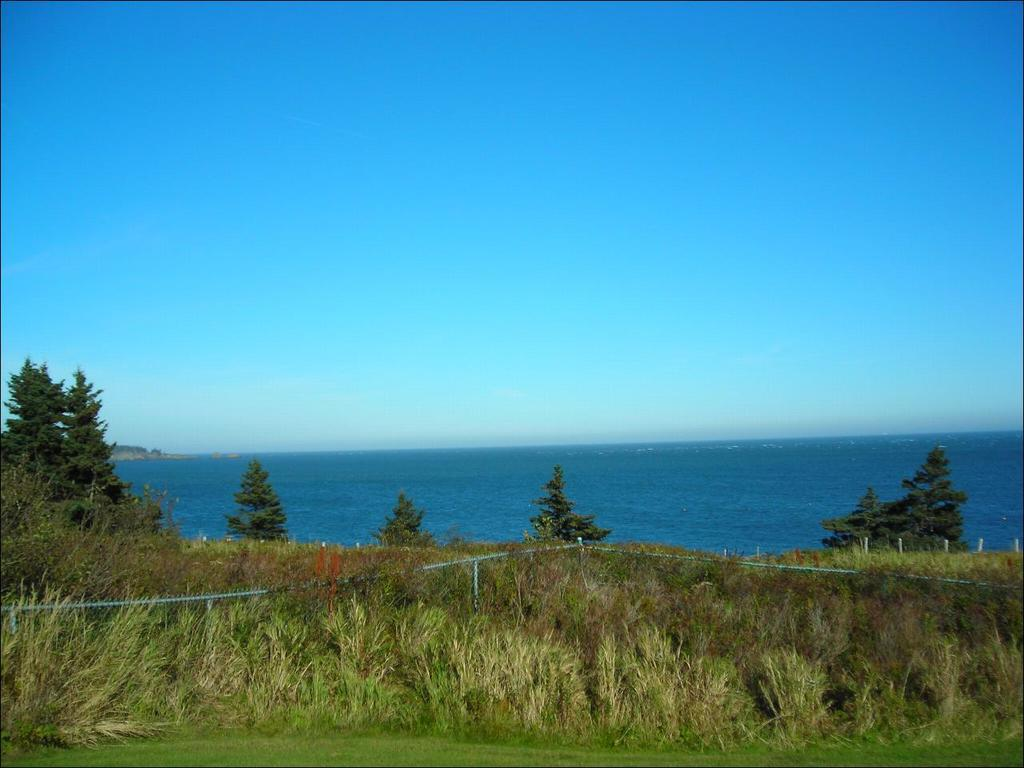What type of vegetation can be seen in the image? There is grass, plants, and trees visible in the image. What natural element is present in the image besides vegetation? There is water visible in the image. What is visible at the top of the image? The sky is visible at the top of the image. What type of popcorn can be seen growing on the trees in the image? There is no popcorn present in the image; it features grass, plants, trees, water, and the sky. What type of trade is taking place in the image? There is no trade taking place in the image; it is a natural scene with vegetation, water, and the sky. 